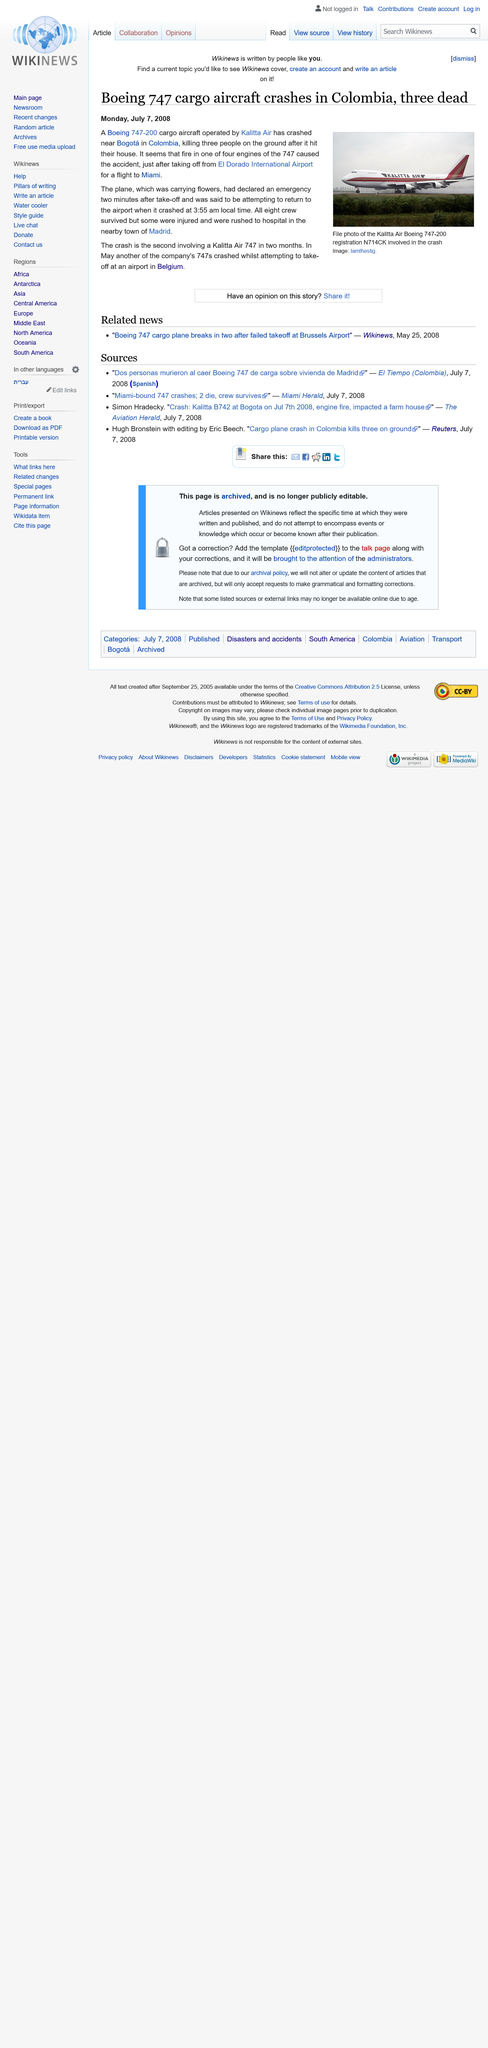List a handful of essential elements in this visual. On Monday, July 7, 2008, the aircraft crashed. The plane was carrying flowers. The Boeing 747-300 cargo aircraft is operated by Kalitta Air. 